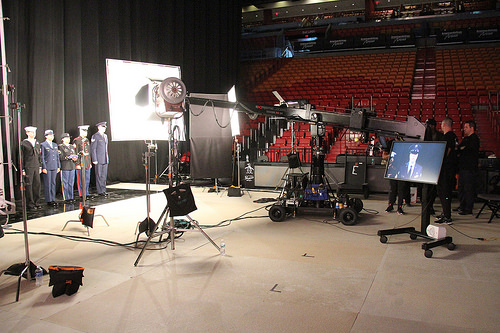<image>
Is the camera boom next to the production crew? Yes. The camera boom is positioned adjacent to the production crew, located nearby in the same general area. 